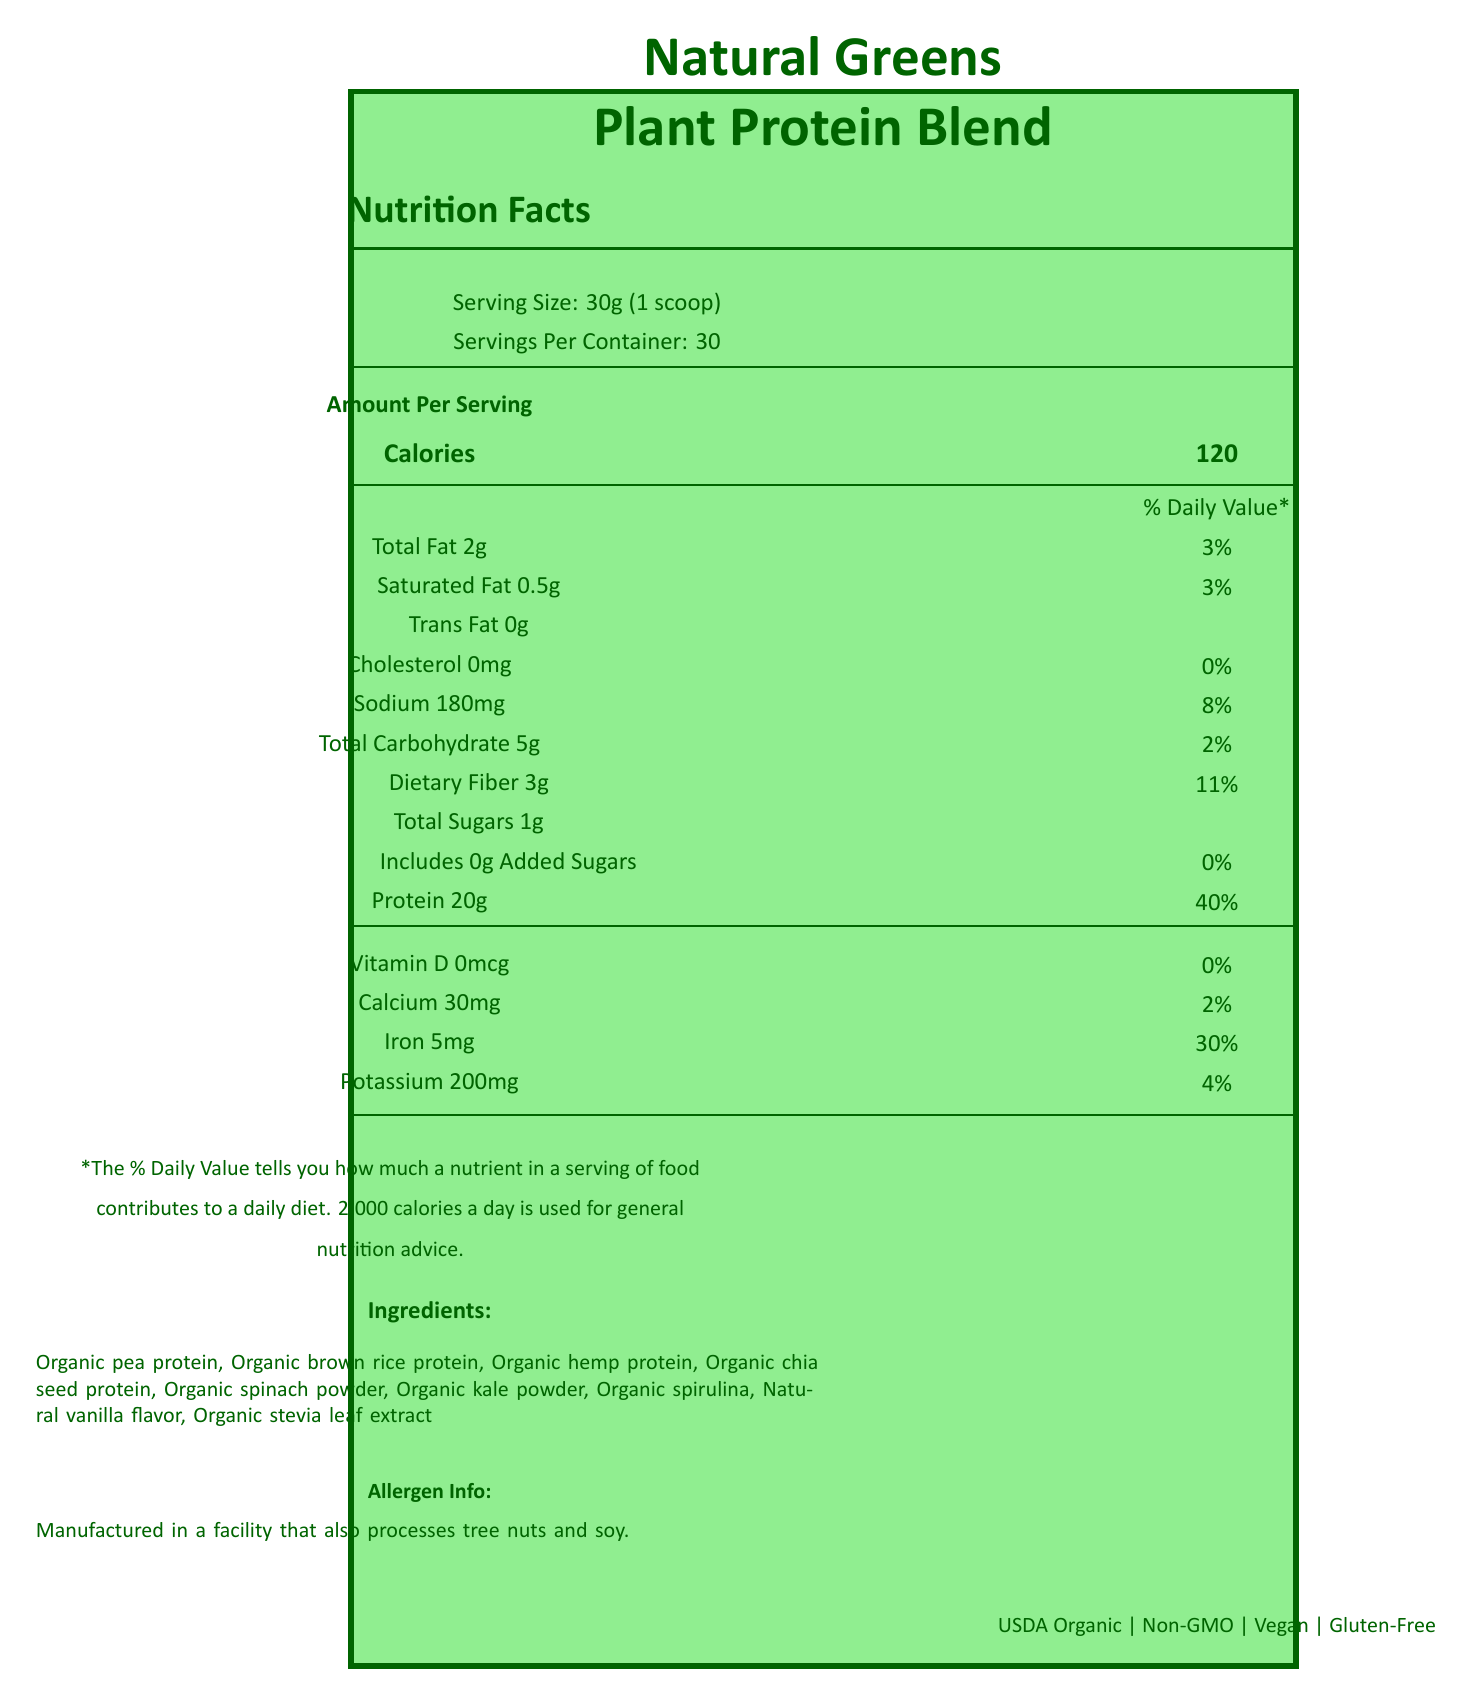what is the serving size? The serving size is explicitly mentioned near the top of the Nutrition Facts section.
Answer: 30g (1 scoop) how many servings per container are there? The document states that there are 30 servings per container.
Answer: 30 how many calories are in one serving? The number of calories per serving is listed in the Nutrition Facts section as 120.
Answer: 120 what is the amount of protein per serving? The protein content per serving is provided in the Nutrition Facts section, listed as 20g.
Answer: 20g what are the total sugars in each serving? The total sugars per serving is stated as 1g in the Nutrition Facts section.
Answer: 1g What are the added sugars in each serving? The added sugars per serving amount to 0g as noted in the Nutrition Facts section.
Answer: 0g how much dietary fiber does one serving contain? The dietary fiber content is listed as 3g per serving in the Nutrition Facts section.
Answer: 3g Which facility processes the product? The allergen information indicates the product is manufactured in a facility that also processes tree nuts and soy.
Answer: Tree nuts and soy facility what is the total amount of fat in one serving? A. 1g B. 2g C. 3g The Nutrition Facts label states that the total fat per serving is 2g.
Answer: B. 2g what percentage of the daily value for iron does one serving contribute?  A. 2% B. 11% C. 30% The daily value for iron per serving is indicated as 30%.
Answer: C. 30% does the product contain any artificial flavors? The document includes a product claim stating there are no artificial flavors, colors, or preservatives.
Answer: No is the product gluten-free? One of the certifications listed is "Gluten-Free."
Answer: Yes does the product contain any cholesterol? The Nutrition Facts section shows that the product contains 0mg of cholesterol.
Answer: No is there any information about synthetic additives in the ingredients? The product claims to have no synthetic additives, as stated in the document.
Answer: No describe the main idea of the document. The document includes a detailed breakdown of the product's nutritional information, ingredients, allergen warnings, certifications, and claims made by the company. The emphasis is on its organic nature, sustainability, and natural components.
Answer: The document is a Nutrition Facts label for "Natural Greens Plant Protein Blend." It provides details about the serving size, nutritional content, amino acid profile, ingredients, allergen information, certifications, and manufacturer details. The label emphasizes the product's organic and non-GMO status, complete amino acid profile, and lack of synthetic additives. where is the company that manufactures the product located? The company information section lists Boulder, Colorado, as the location.
Answer: Boulder, Colorado which amino acid is present in the highest amount? The amino acid profile lists glutamic acid as the highest, with 3400mg per serving.
Answer: Glutamic Acid how much calcium does one serving provide? The Nutrition Facts section indicates that each serving contains 30mg of calcium.
Answer: 30mg who manufacturers the product? A. Earth Nutrition B. Green Earth Nutrition C. Organic Greens Inc. The company name is provided in the company information section as "Green Earth Nutrition."
Answer: B. Green Earth Nutrition what is the company's mission statement? The mission statement is explicitly mentioned in the company information section.
Answer: Providing honest, clean nutrition while supporting sustainable agriculture and local communities. how many calories are needed per day for general nutrition advice? The footnote specifies that 2,000 calories a day is used for general nutrition advice.
Answer: 2,000 calories does the product support local organic farmers? One of the product claims is that it supports local organic farmers.
Answer: Yes what is the exact amount of isoleucine present per serving? The amino acid profile lists isoleucine with an amount of 1050mg per serving.
Answer: 1050mg what is the source of sweetness in the product? The ingredients list "Organic stevia leaf extract" as the source of sweetness.
Answer: Organic stevia leaf extract how much potassium does each serving provide? The Nutrition Facts section states 200mg of potassium per serving.
Answer: 200mg is the company's website provided in the document? The company's website, "www.greenearthnutrition.com," is listed in the company information section.
Answer: Yes are there any monosodium glutamate (MSG) contents in this product? The document does not provide specific information about MSG content.
Answer: Not enough information what makes the product suitable for vegans? The product's suitability for vegans is indicated by its plant-based protein sources and the "Vegan" certification.
Answer: Plant-based protein and certifications 